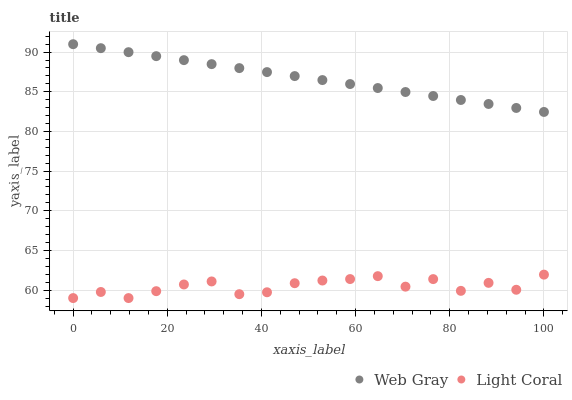Does Light Coral have the minimum area under the curve?
Answer yes or no. Yes. Does Web Gray have the maximum area under the curve?
Answer yes or no. Yes. Does Web Gray have the minimum area under the curve?
Answer yes or no. No. Is Web Gray the smoothest?
Answer yes or no. Yes. Is Light Coral the roughest?
Answer yes or no. Yes. Is Web Gray the roughest?
Answer yes or no. No. Does Light Coral have the lowest value?
Answer yes or no. Yes. Does Web Gray have the lowest value?
Answer yes or no. No. Does Web Gray have the highest value?
Answer yes or no. Yes. Is Light Coral less than Web Gray?
Answer yes or no. Yes. Is Web Gray greater than Light Coral?
Answer yes or no. Yes. Does Light Coral intersect Web Gray?
Answer yes or no. No. 